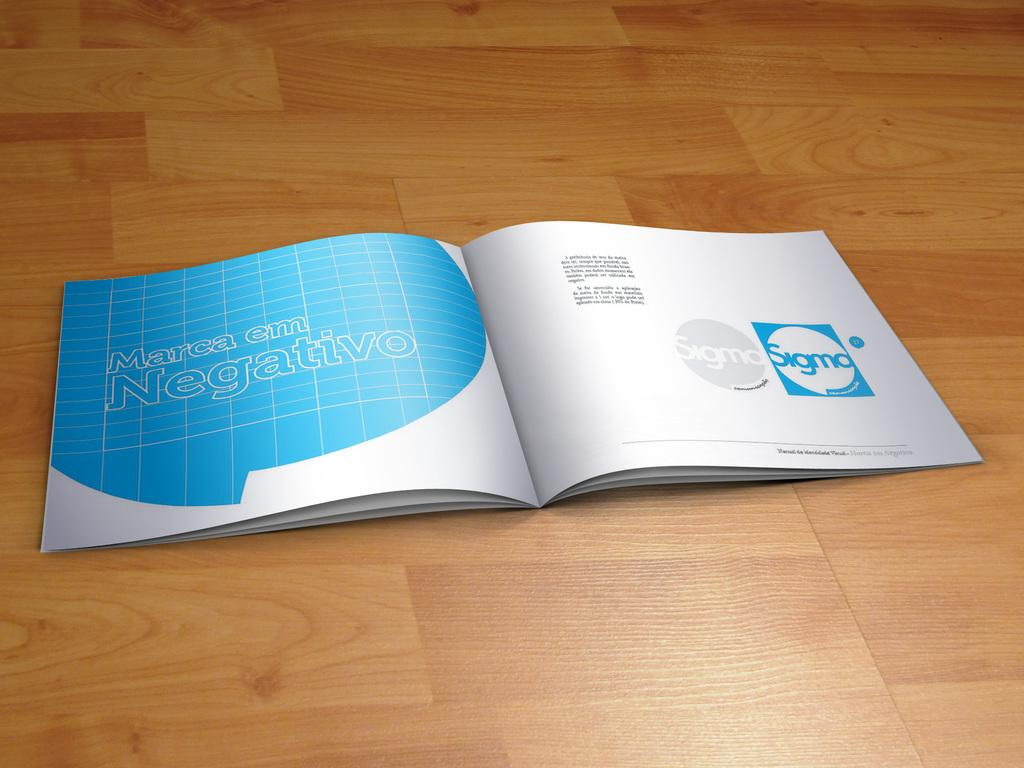<image>
Summarize the visual content of the image. A rendering of an open book with the words "Marca em Negativo" on the left page. 